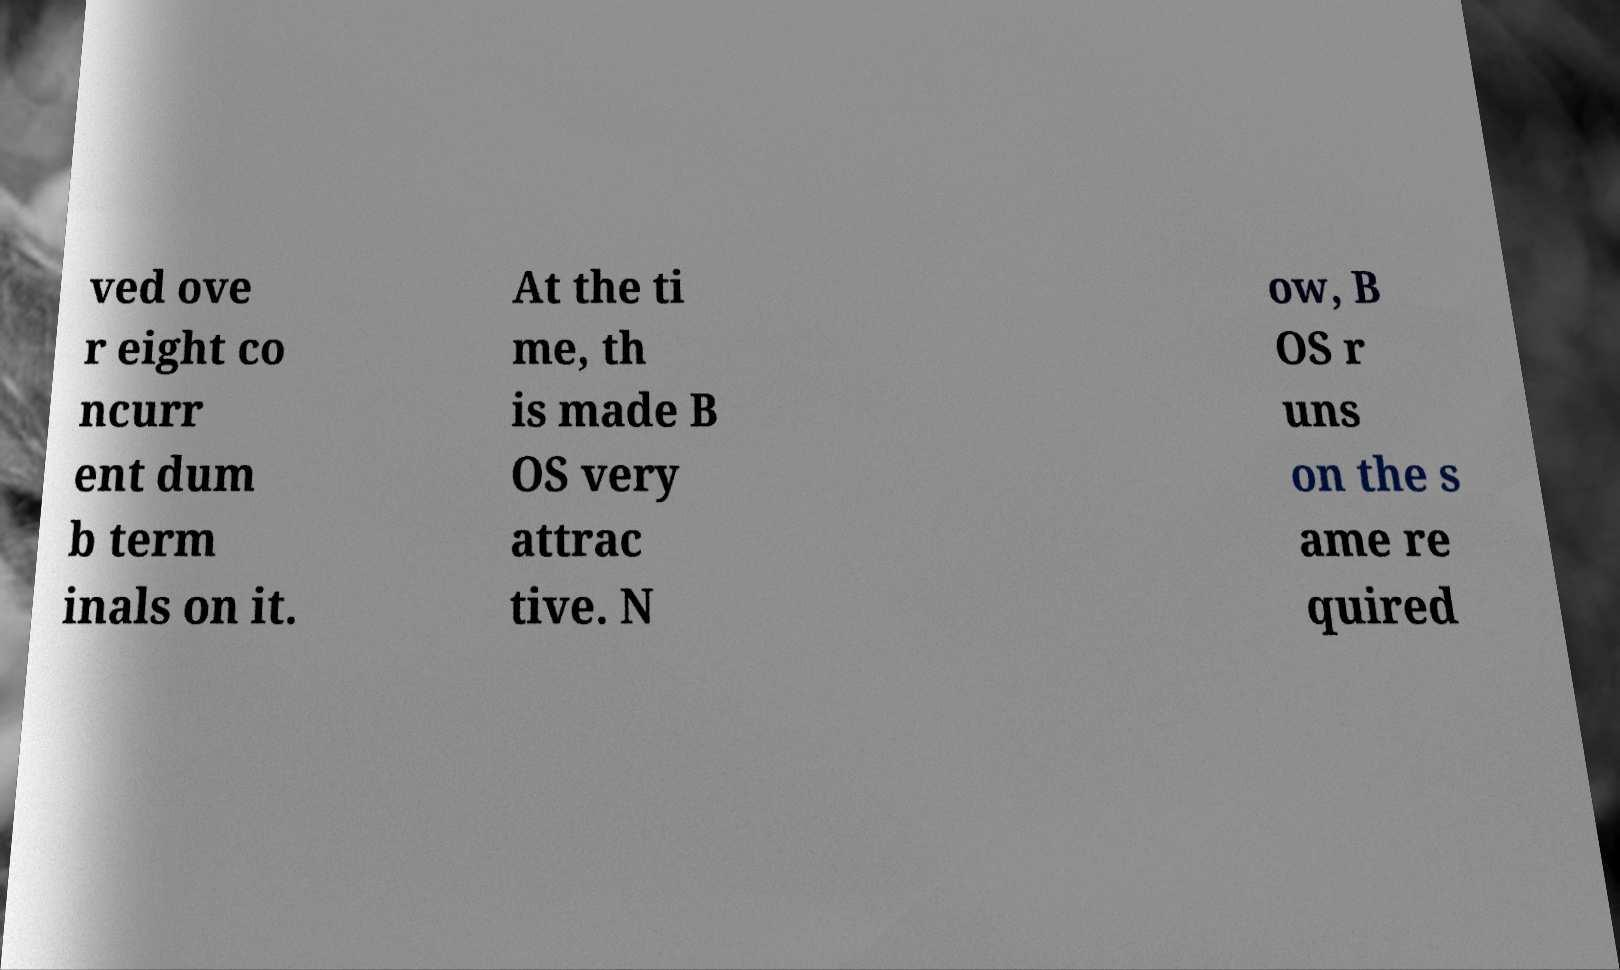Could you assist in decoding the text presented in this image and type it out clearly? ved ove r eight co ncurr ent dum b term inals on it. At the ti me, th is made B OS very attrac tive. N ow, B OS r uns on the s ame re quired 